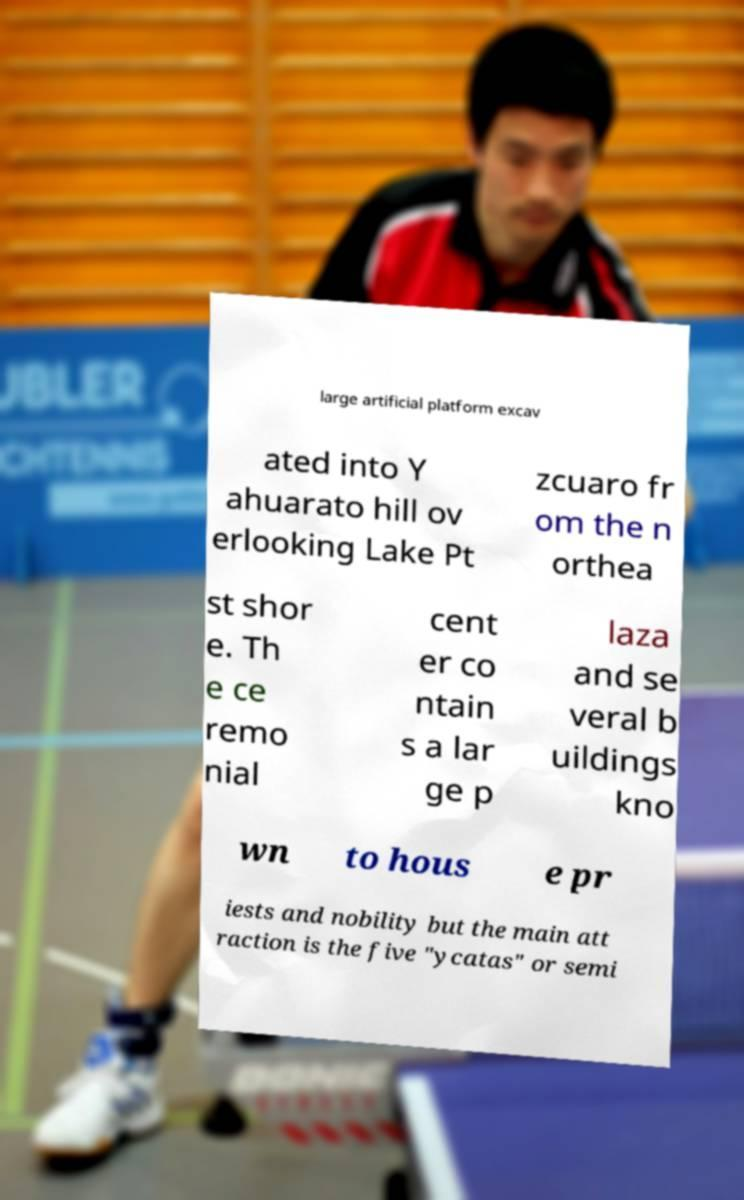Can you read and provide the text displayed in the image?This photo seems to have some interesting text. Can you extract and type it out for me? large artificial platform excav ated into Y ahuarato hill ov erlooking Lake Pt zcuaro fr om the n orthea st shor e. Th e ce remo nial cent er co ntain s a lar ge p laza and se veral b uildings kno wn to hous e pr iests and nobility but the main att raction is the five "ycatas" or semi 